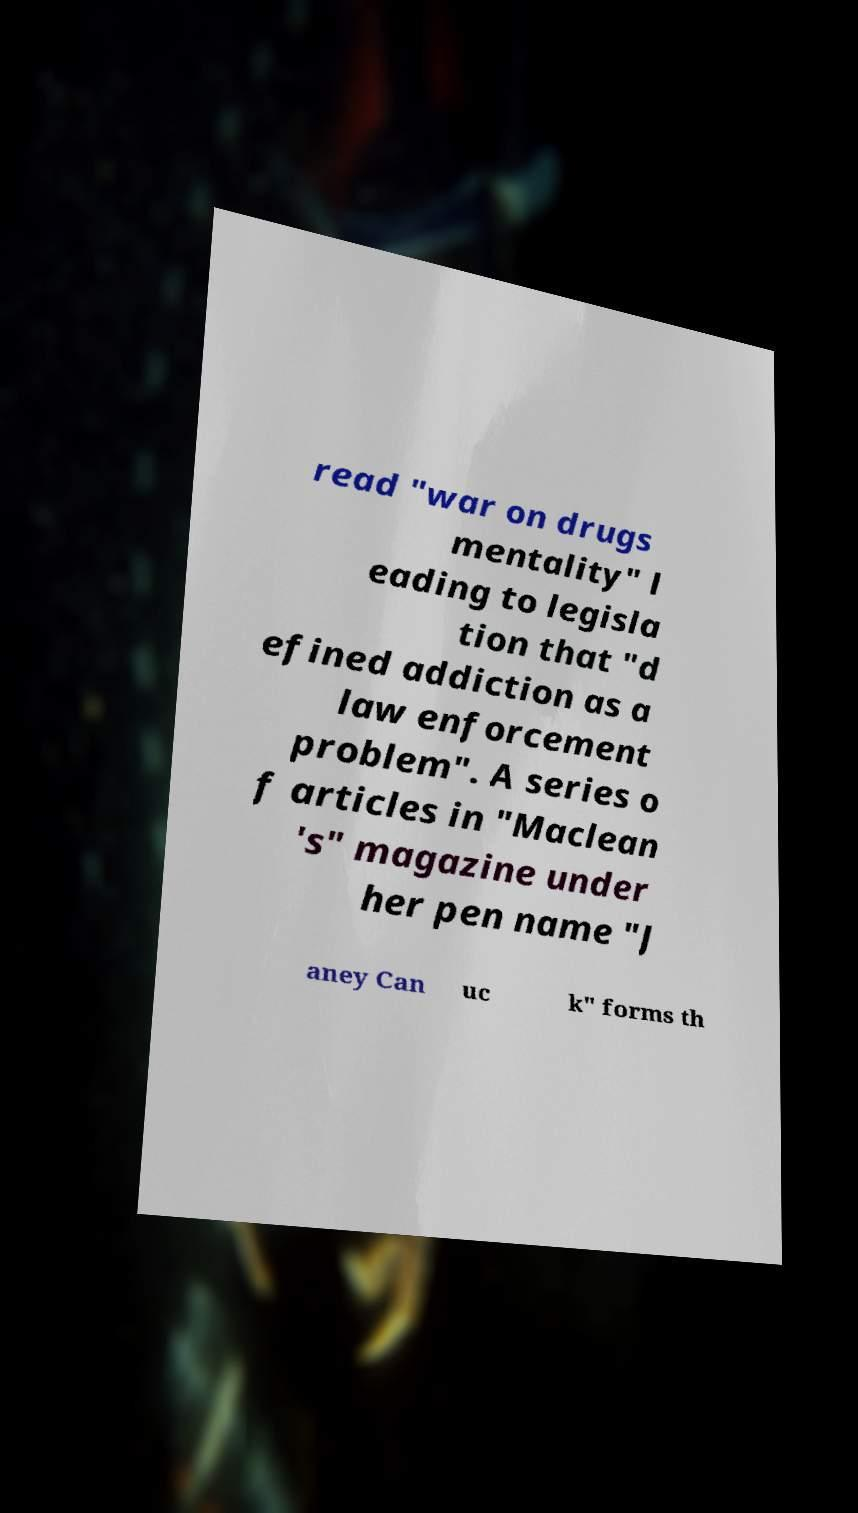Could you assist in decoding the text presented in this image and type it out clearly? read "war on drugs mentality" l eading to legisla tion that "d efined addiction as a law enforcement problem". A series o f articles in "Maclean 's" magazine under her pen name "J aney Can uc k" forms th 